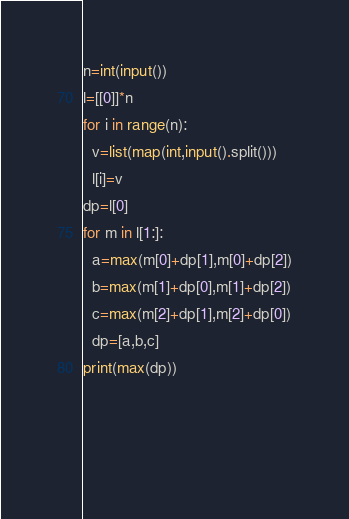<code> <loc_0><loc_0><loc_500><loc_500><_Python_>n=int(input())
l=[[0]]*n
for i in range(n):
  v=list(map(int,input().split()))
  l[i]=v
dp=l[0]
for m in l[1:]:
  a=max(m[0]+dp[1],m[0]+dp[2])
  b=max(m[1]+dp[0],m[1]+dp[2])
  c=max(m[2]+dp[1],m[2]+dp[0])
  dp=[a,b,c]
print(max(dp))
  
  
  </code> 